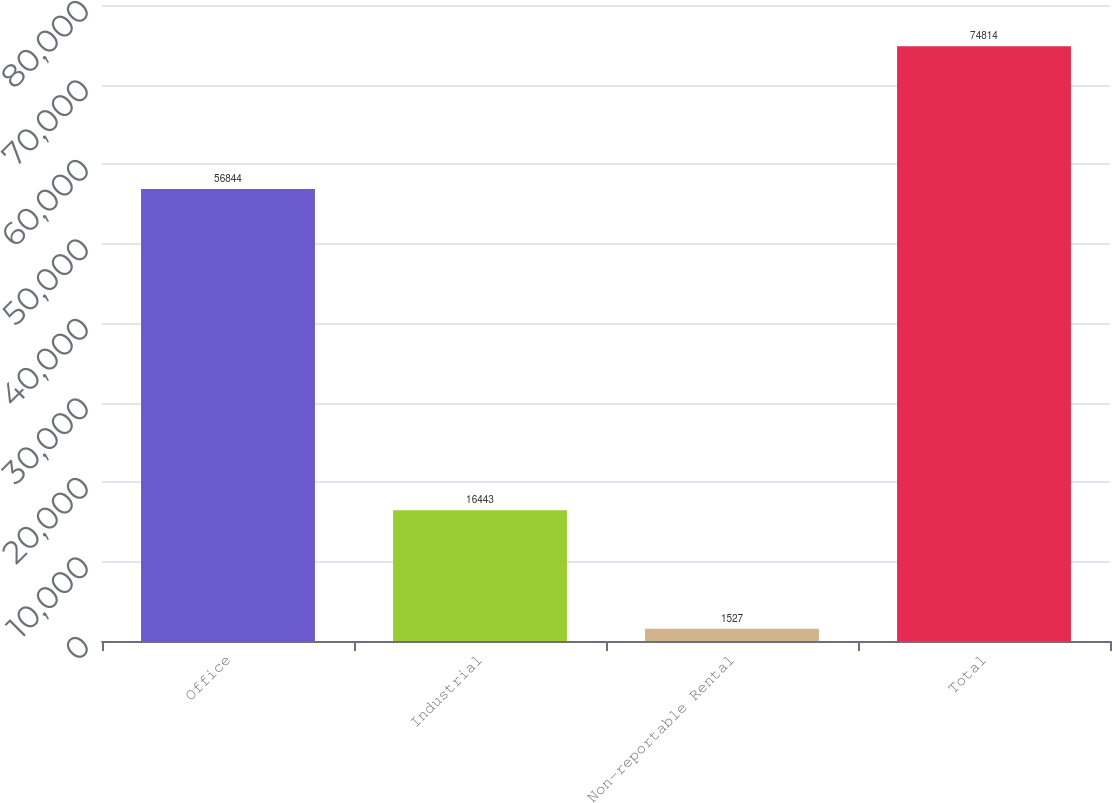Convert chart. <chart><loc_0><loc_0><loc_500><loc_500><bar_chart><fcel>Office<fcel>Industrial<fcel>Non-reportable Rental<fcel>Total<nl><fcel>56844<fcel>16443<fcel>1527<fcel>74814<nl></chart> 